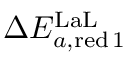Convert formula to latex. <formula><loc_0><loc_0><loc_500><loc_500>\Delta E _ { a , r e d \, 1 } ^ { L a L }</formula> 